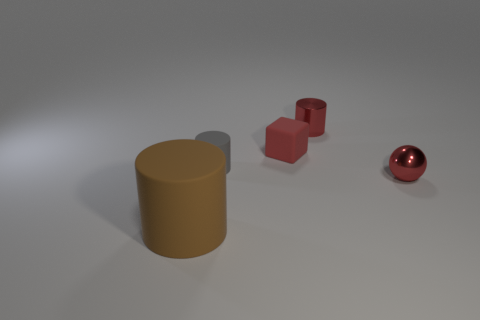What can we infer about the source of light in this image? Given the shadows cast by the objects and the highlights visible on the sphere and the red cubes, we can infer that the light source is situated above and to the right side of the frame, out of the image's view. The light appears to be diffused, as there are no harsh shadows, suggesting a softbox or similar lighting setup that softens the light for a natural effect. 